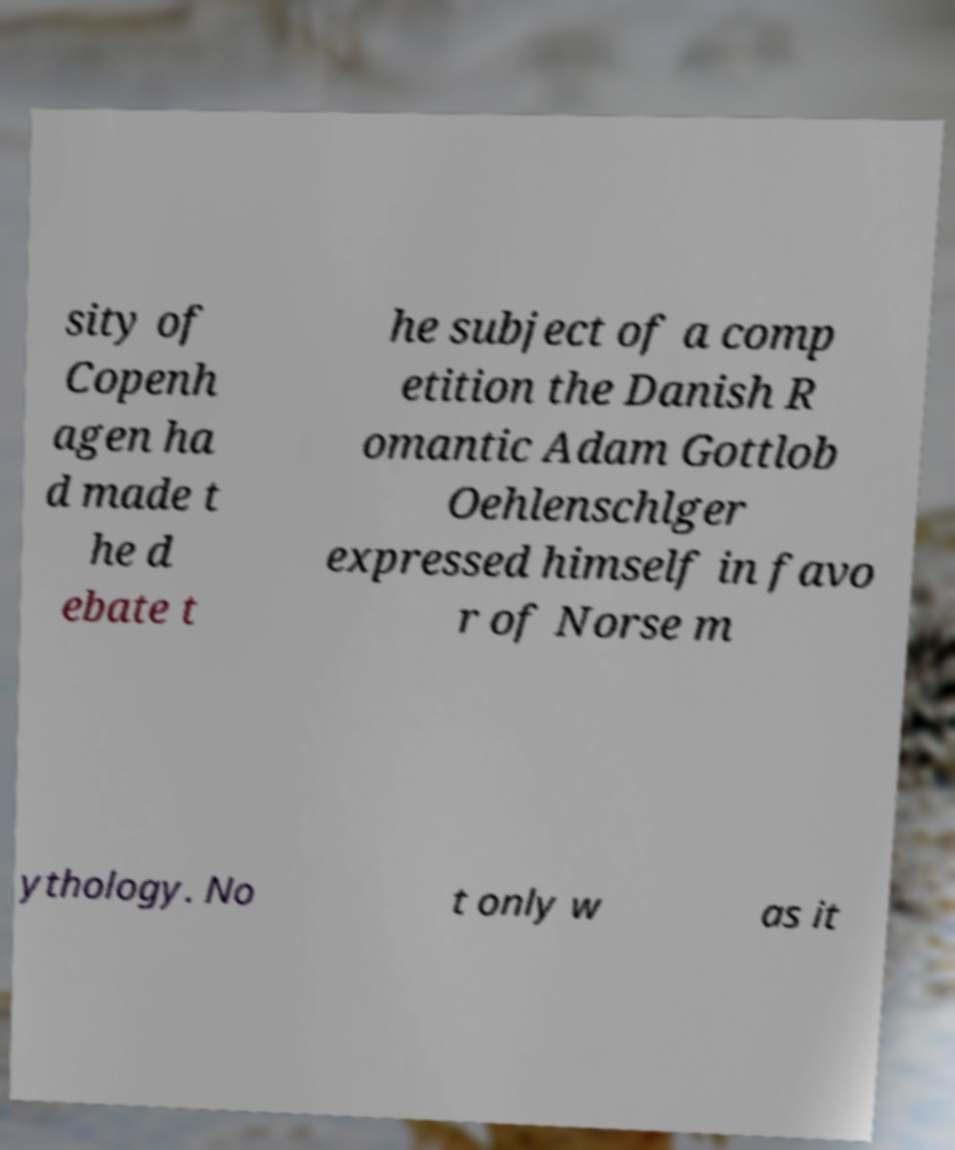Can you read and provide the text displayed in the image?This photo seems to have some interesting text. Can you extract and type it out for me? sity of Copenh agen ha d made t he d ebate t he subject of a comp etition the Danish R omantic Adam Gottlob Oehlenschlger expressed himself in favo r of Norse m ythology. No t only w as it 